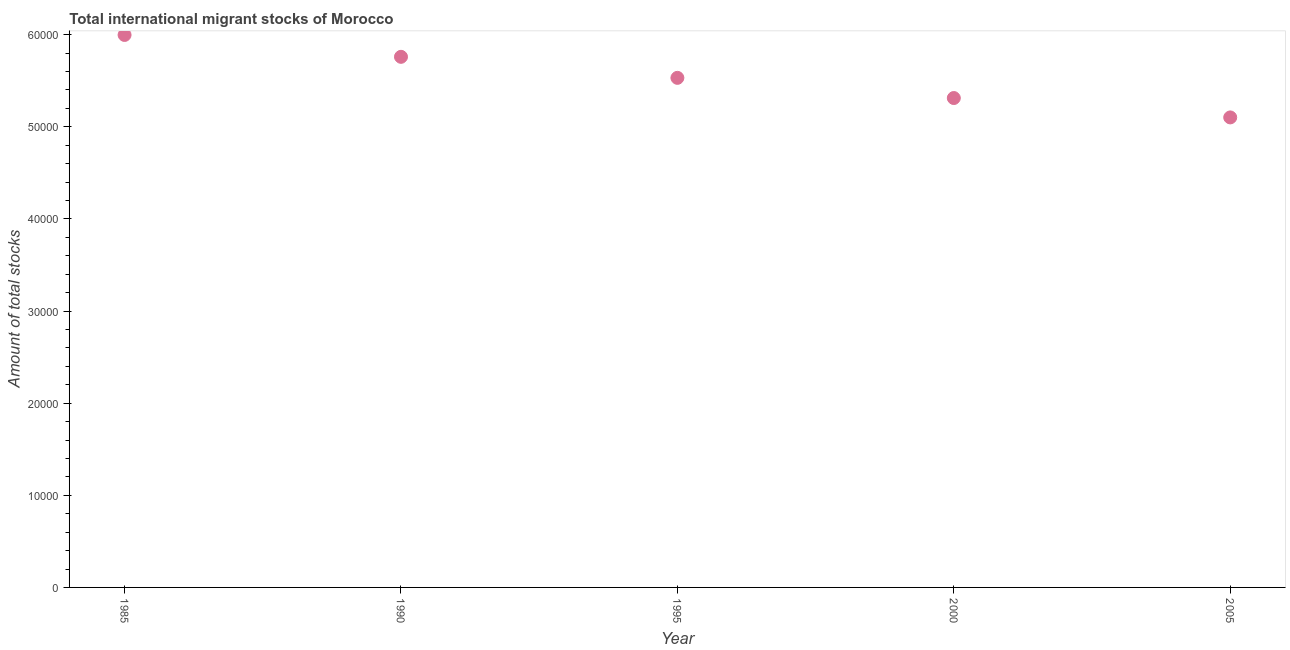What is the total number of international migrant stock in 1995?
Ensure brevity in your answer.  5.53e+04. Across all years, what is the maximum total number of international migrant stock?
Give a very brief answer. 6.00e+04. Across all years, what is the minimum total number of international migrant stock?
Give a very brief answer. 5.10e+04. In which year was the total number of international migrant stock maximum?
Make the answer very short. 1985. What is the sum of the total number of international migrant stock?
Keep it short and to the point. 2.77e+05. What is the difference between the total number of international migrant stock in 1990 and 1995?
Offer a terse response. 2282. What is the average total number of international migrant stock per year?
Make the answer very short. 5.54e+04. What is the median total number of international migrant stock?
Your response must be concise. 5.53e+04. In how many years, is the total number of international migrant stock greater than 52000 ?
Ensure brevity in your answer.  4. What is the ratio of the total number of international migrant stock in 1990 to that in 1995?
Your answer should be compact. 1.04. Is the total number of international migrant stock in 1990 less than that in 2000?
Keep it short and to the point. No. Is the difference between the total number of international migrant stock in 1990 and 2000 greater than the difference between any two years?
Give a very brief answer. No. What is the difference between the highest and the second highest total number of international migrant stock?
Keep it short and to the point. 2375. What is the difference between the highest and the lowest total number of international migrant stock?
Give a very brief answer. 8952. In how many years, is the total number of international migrant stock greater than the average total number of international migrant stock taken over all years?
Make the answer very short. 2. How many dotlines are there?
Offer a terse response. 1. What is the difference between two consecutive major ticks on the Y-axis?
Ensure brevity in your answer.  10000. Are the values on the major ticks of Y-axis written in scientific E-notation?
Ensure brevity in your answer.  No. Does the graph contain any zero values?
Give a very brief answer. No. What is the title of the graph?
Keep it short and to the point. Total international migrant stocks of Morocco. What is the label or title of the Y-axis?
Your answer should be compact. Amount of total stocks. What is the Amount of total stocks in 1985?
Offer a very short reply. 6.00e+04. What is the Amount of total stocks in 1990?
Provide a succinct answer. 5.76e+04. What is the Amount of total stocks in 1995?
Provide a succinct answer. 5.53e+04. What is the Amount of total stocks in 2000?
Offer a terse response. 5.31e+04. What is the Amount of total stocks in 2005?
Offer a very short reply. 5.10e+04. What is the difference between the Amount of total stocks in 1985 and 1990?
Provide a succinct answer. 2375. What is the difference between the Amount of total stocks in 1985 and 1995?
Provide a succinct answer. 4657. What is the difference between the Amount of total stocks in 1985 and 2000?
Your answer should be very brief. 6848. What is the difference between the Amount of total stocks in 1985 and 2005?
Provide a short and direct response. 8952. What is the difference between the Amount of total stocks in 1990 and 1995?
Ensure brevity in your answer.  2282. What is the difference between the Amount of total stocks in 1990 and 2000?
Make the answer very short. 4473. What is the difference between the Amount of total stocks in 1990 and 2005?
Make the answer very short. 6577. What is the difference between the Amount of total stocks in 1995 and 2000?
Give a very brief answer. 2191. What is the difference between the Amount of total stocks in 1995 and 2005?
Your response must be concise. 4295. What is the difference between the Amount of total stocks in 2000 and 2005?
Keep it short and to the point. 2104. What is the ratio of the Amount of total stocks in 1985 to that in 1990?
Provide a succinct answer. 1.04. What is the ratio of the Amount of total stocks in 1985 to that in 1995?
Provide a short and direct response. 1.08. What is the ratio of the Amount of total stocks in 1985 to that in 2000?
Make the answer very short. 1.13. What is the ratio of the Amount of total stocks in 1985 to that in 2005?
Offer a very short reply. 1.18. What is the ratio of the Amount of total stocks in 1990 to that in 1995?
Offer a very short reply. 1.04. What is the ratio of the Amount of total stocks in 1990 to that in 2000?
Keep it short and to the point. 1.08. What is the ratio of the Amount of total stocks in 1990 to that in 2005?
Provide a succinct answer. 1.13. What is the ratio of the Amount of total stocks in 1995 to that in 2000?
Ensure brevity in your answer.  1.04. What is the ratio of the Amount of total stocks in 1995 to that in 2005?
Give a very brief answer. 1.08. What is the ratio of the Amount of total stocks in 2000 to that in 2005?
Your answer should be compact. 1.04. 